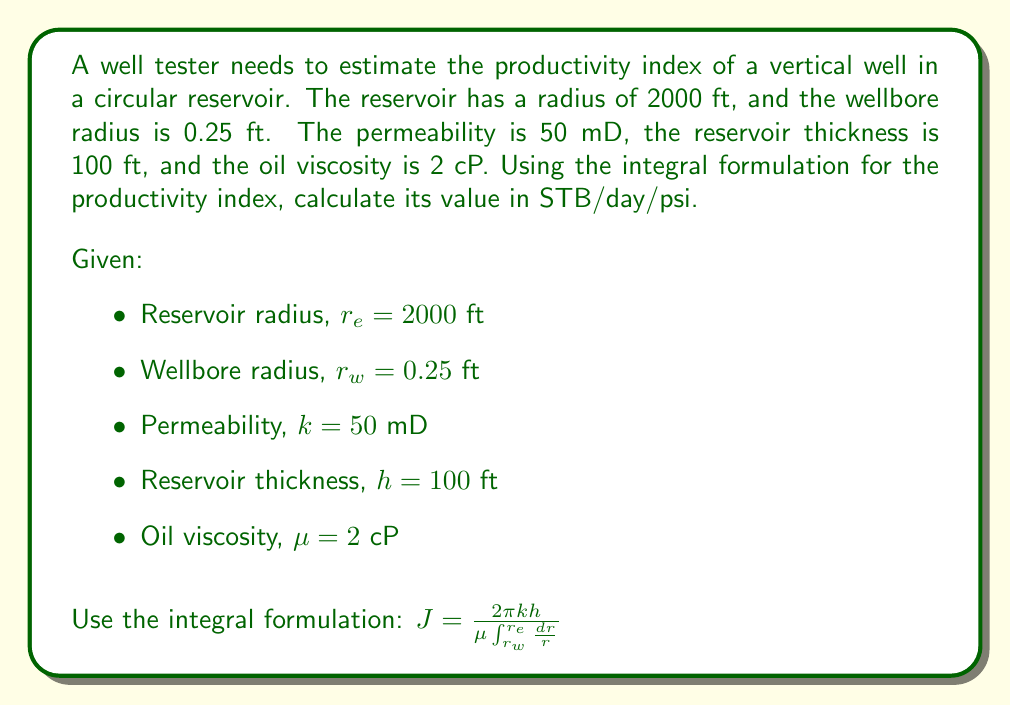Can you solve this math problem? To estimate the productivity index using the integral formulation, we'll follow these steps:

1) Start with the given integral formulation:

   $J = \frac{2\pi kh}{\mu \int_{r_w}^{r_e} \frac{dr}{r}}$

2) Evaluate the integral in the denominator:

   $\int_{r_w}^{r_e} \frac{dr}{r} = \ln(r) \big|_{r_w}^{r_e} = \ln(r_e) - \ln(r_w) = \ln(\frac{r_e}{r_w})$

3) Substitute this result back into the equation:

   $J = \frac{2\pi kh}{\mu \ln(\frac{r_e}{r_w})}$

4) Now, let's substitute the given values:
   
   $J = \frac{2\pi \cdot 50 \cdot 10^{-3} \cdot 100}{2 \cdot \ln(\frac{2000}{0.25})}$

5) Simplify:
   
   $J = \frac{31.4159}{2 \cdot \ln(8000)} = \frac{31.4159}{2 \cdot 8.9872} = 1.7483$

6) Convert units:
   The result is in darcy-ft/cP, which we need to convert to STB/day/psi.
   
   Conversion factor: 1 darcy-ft/cP = 0.00708 STB/day/psi

   $J = 1.7483 \cdot 0.00708 = 0.01238$ STB/day/psi

Therefore, the productivity index is approximately 0.01238 STB/day/psi.
Answer: 0.01238 STB/day/psi 